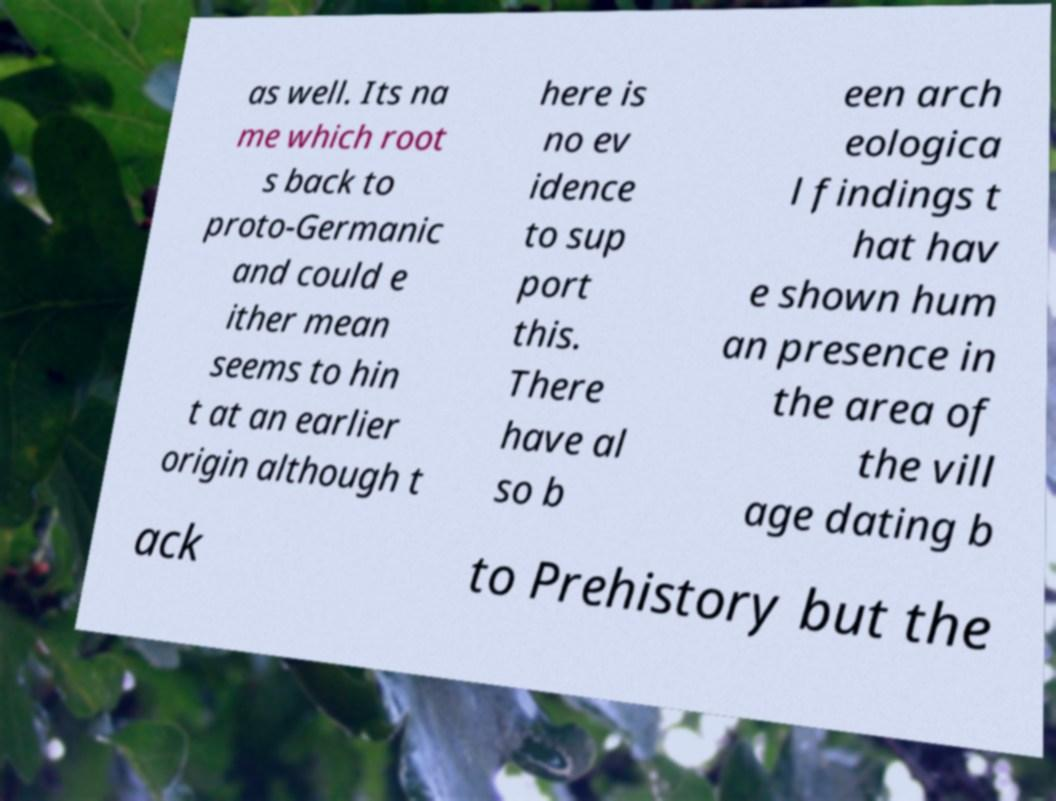What messages or text are displayed in this image? I need them in a readable, typed format. as well. Its na me which root s back to proto-Germanic and could e ither mean seems to hin t at an earlier origin although t here is no ev idence to sup port this. There have al so b een arch eologica l findings t hat hav e shown hum an presence in the area of the vill age dating b ack to Prehistory but the 